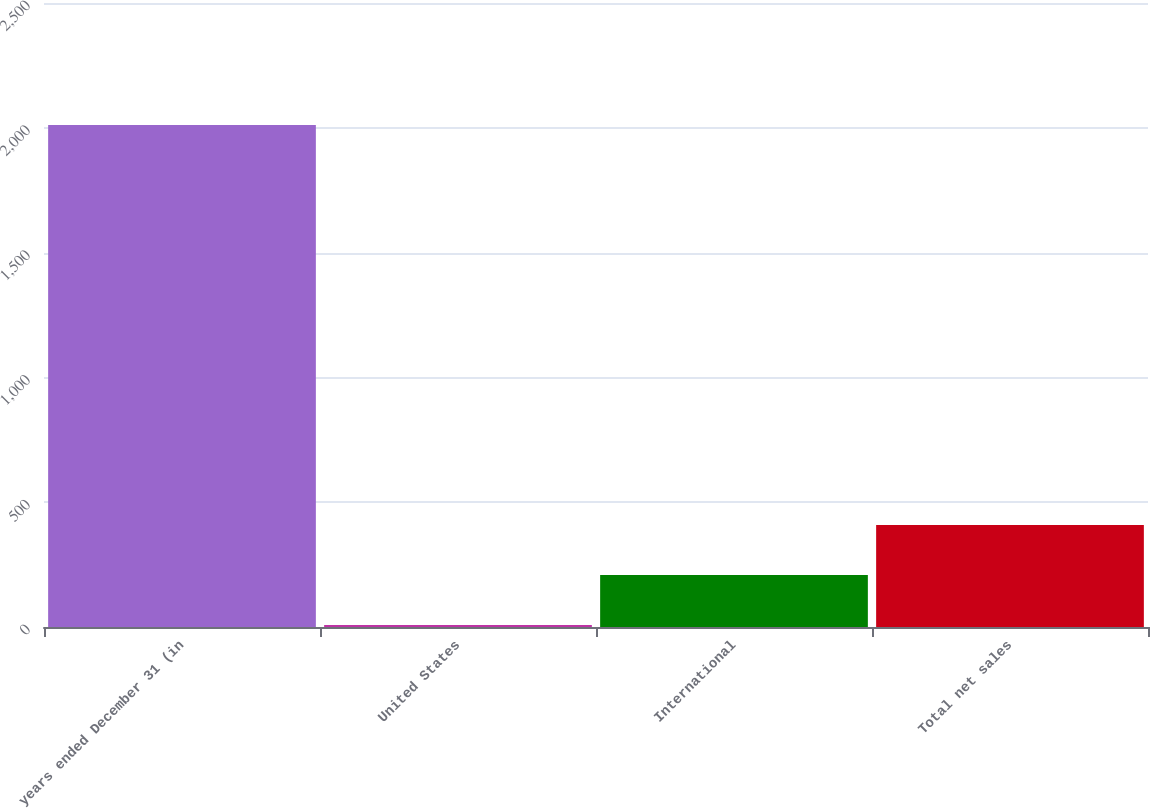Convert chart. <chart><loc_0><loc_0><loc_500><loc_500><bar_chart><fcel>years ended December 31 (in<fcel>United States<fcel>International<fcel>Total net sales<nl><fcel>2011<fcel>8<fcel>208.3<fcel>408.6<nl></chart> 